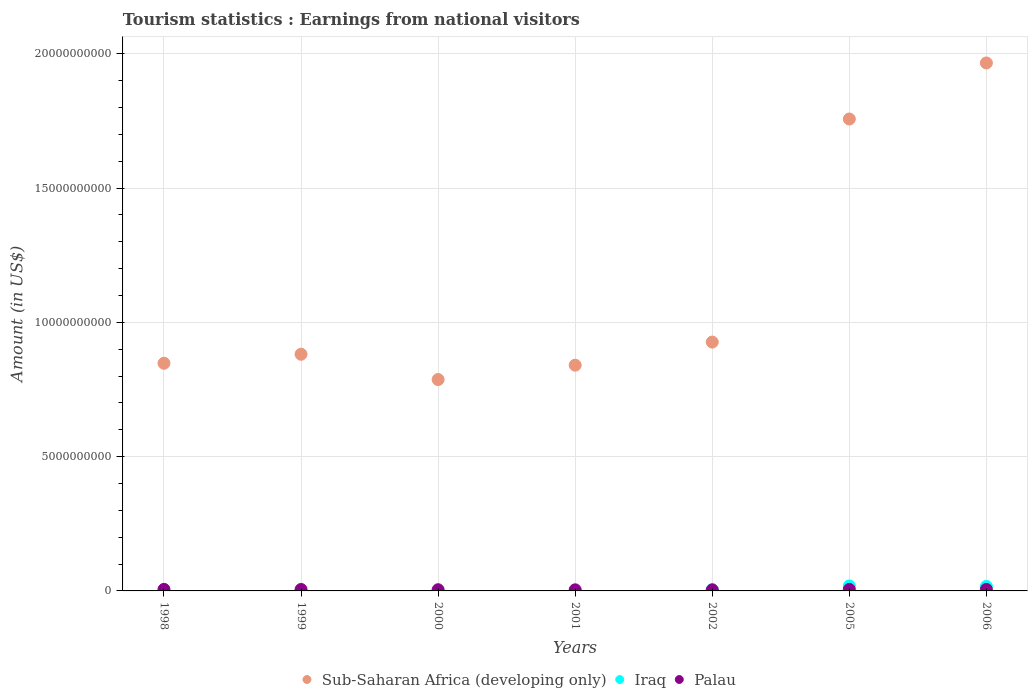What is the earnings from national visitors in Iraq in 2006?
Your answer should be compact. 1.70e+08. Across all years, what is the maximum earnings from national visitors in Iraq?
Provide a short and direct response. 1.86e+08. Across all years, what is the minimum earnings from national visitors in Palau?
Your answer should be very brief. 4.00e+07. In which year was the earnings from national visitors in Palau minimum?
Ensure brevity in your answer.  2002. What is the total earnings from national visitors in Palau in the graph?
Your response must be concise. 3.53e+08. What is the difference between the earnings from national visitors in Iraq in 2000 and that in 2001?
Offer a terse response. -1.30e+07. What is the difference between the earnings from national visitors in Iraq in 2006 and the earnings from national visitors in Palau in 2000?
Keep it short and to the point. 1.25e+08. What is the average earnings from national visitors in Sub-Saharan Africa (developing only) per year?
Your response must be concise. 1.14e+1. In the year 2006, what is the difference between the earnings from national visitors in Sub-Saharan Africa (developing only) and earnings from national visitors in Iraq?
Ensure brevity in your answer.  1.95e+1. What is the ratio of the earnings from national visitors in Iraq in 2005 to that in 2006?
Offer a very short reply. 1.09. Is the difference between the earnings from national visitors in Sub-Saharan Africa (developing only) in 2001 and 2005 greater than the difference between the earnings from national visitors in Iraq in 2001 and 2005?
Provide a succinct answer. No. What is the difference between the highest and the second highest earnings from national visitors in Iraq?
Offer a very short reply. 1.60e+07. What is the difference between the highest and the lowest earnings from national visitors in Palau?
Offer a terse response. 1.80e+07. In how many years, is the earnings from national visitors in Palau greater than the average earnings from national visitors in Palau taken over all years?
Ensure brevity in your answer.  4. Does the earnings from national visitors in Palau monotonically increase over the years?
Offer a terse response. No. Is the earnings from national visitors in Palau strictly greater than the earnings from national visitors in Sub-Saharan Africa (developing only) over the years?
Your answer should be compact. No. Is the earnings from national visitors in Sub-Saharan Africa (developing only) strictly less than the earnings from national visitors in Iraq over the years?
Your answer should be very brief. No. How many years are there in the graph?
Keep it short and to the point. 7. Does the graph contain any zero values?
Your answer should be compact. No. Does the graph contain grids?
Your answer should be very brief. Yes. Where does the legend appear in the graph?
Keep it short and to the point. Bottom center. How many legend labels are there?
Offer a terse response. 3. How are the legend labels stacked?
Offer a terse response. Horizontal. What is the title of the graph?
Your answer should be compact. Tourism statistics : Earnings from national visitors. Does "Lesotho" appear as one of the legend labels in the graph?
Your answer should be very brief. No. What is the Amount (in US$) of Sub-Saharan Africa (developing only) in 1998?
Make the answer very short. 8.48e+09. What is the Amount (in US$) of Iraq in 1998?
Keep it short and to the point. 1.50e+07. What is the Amount (in US$) of Palau in 1998?
Offer a very short reply. 5.80e+07. What is the Amount (in US$) in Sub-Saharan Africa (developing only) in 1999?
Your answer should be very brief. 8.81e+09. What is the Amount (in US$) of Palau in 1999?
Give a very brief answer. 5.40e+07. What is the Amount (in US$) in Sub-Saharan Africa (developing only) in 2000?
Ensure brevity in your answer.  7.87e+09. What is the Amount (in US$) in Palau in 2000?
Provide a succinct answer. 4.50e+07. What is the Amount (in US$) of Sub-Saharan Africa (developing only) in 2001?
Your answer should be compact. 8.41e+09. What is the Amount (in US$) in Iraq in 2001?
Ensure brevity in your answer.  1.50e+07. What is the Amount (in US$) of Palau in 2001?
Your response must be concise. 4.10e+07. What is the Amount (in US$) in Sub-Saharan Africa (developing only) in 2002?
Keep it short and to the point. 9.27e+09. What is the Amount (in US$) in Iraq in 2002?
Make the answer very short. 4.50e+07. What is the Amount (in US$) of Palau in 2002?
Your answer should be very brief. 4.00e+07. What is the Amount (in US$) in Sub-Saharan Africa (developing only) in 2005?
Ensure brevity in your answer.  1.76e+1. What is the Amount (in US$) in Iraq in 2005?
Offer a terse response. 1.86e+08. What is the Amount (in US$) of Palau in 2005?
Keep it short and to the point. 5.70e+07. What is the Amount (in US$) of Sub-Saharan Africa (developing only) in 2006?
Keep it short and to the point. 1.97e+1. What is the Amount (in US$) of Iraq in 2006?
Provide a succinct answer. 1.70e+08. What is the Amount (in US$) of Palau in 2006?
Offer a very short reply. 5.80e+07. Across all years, what is the maximum Amount (in US$) in Sub-Saharan Africa (developing only)?
Provide a short and direct response. 1.97e+1. Across all years, what is the maximum Amount (in US$) of Iraq?
Offer a terse response. 1.86e+08. Across all years, what is the maximum Amount (in US$) in Palau?
Keep it short and to the point. 5.80e+07. Across all years, what is the minimum Amount (in US$) of Sub-Saharan Africa (developing only)?
Your answer should be very brief. 7.87e+09. Across all years, what is the minimum Amount (in US$) of Iraq?
Offer a very short reply. 1.00e+06. Across all years, what is the minimum Amount (in US$) in Palau?
Keep it short and to the point. 4.00e+07. What is the total Amount (in US$) of Sub-Saharan Africa (developing only) in the graph?
Make the answer very short. 8.01e+1. What is the total Amount (in US$) of Iraq in the graph?
Provide a succinct answer. 4.34e+08. What is the total Amount (in US$) in Palau in the graph?
Offer a very short reply. 3.53e+08. What is the difference between the Amount (in US$) in Sub-Saharan Africa (developing only) in 1998 and that in 1999?
Offer a very short reply. -3.36e+08. What is the difference between the Amount (in US$) of Iraq in 1998 and that in 1999?
Keep it short and to the point. 1.40e+07. What is the difference between the Amount (in US$) of Sub-Saharan Africa (developing only) in 1998 and that in 2000?
Your response must be concise. 6.06e+08. What is the difference between the Amount (in US$) in Iraq in 1998 and that in 2000?
Ensure brevity in your answer.  1.30e+07. What is the difference between the Amount (in US$) in Palau in 1998 and that in 2000?
Provide a short and direct response. 1.30e+07. What is the difference between the Amount (in US$) of Sub-Saharan Africa (developing only) in 1998 and that in 2001?
Make the answer very short. 7.12e+07. What is the difference between the Amount (in US$) of Palau in 1998 and that in 2001?
Provide a short and direct response. 1.70e+07. What is the difference between the Amount (in US$) of Sub-Saharan Africa (developing only) in 1998 and that in 2002?
Your answer should be very brief. -7.90e+08. What is the difference between the Amount (in US$) in Iraq in 1998 and that in 2002?
Offer a terse response. -3.00e+07. What is the difference between the Amount (in US$) of Palau in 1998 and that in 2002?
Your answer should be compact. 1.80e+07. What is the difference between the Amount (in US$) in Sub-Saharan Africa (developing only) in 1998 and that in 2005?
Make the answer very short. -9.10e+09. What is the difference between the Amount (in US$) in Iraq in 1998 and that in 2005?
Offer a terse response. -1.71e+08. What is the difference between the Amount (in US$) of Sub-Saharan Africa (developing only) in 1998 and that in 2006?
Offer a terse response. -1.12e+1. What is the difference between the Amount (in US$) in Iraq in 1998 and that in 2006?
Keep it short and to the point. -1.55e+08. What is the difference between the Amount (in US$) of Sub-Saharan Africa (developing only) in 1999 and that in 2000?
Offer a terse response. 9.42e+08. What is the difference between the Amount (in US$) of Iraq in 1999 and that in 2000?
Keep it short and to the point. -1.00e+06. What is the difference between the Amount (in US$) of Palau in 1999 and that in 2000?
Ensure brevity in your answer.  9.00e+06. What is the difference between the Amount (in US$) of Sub-Saharan Africa (developing only) in 1999 and that in 2001?
Provide a short and direct response. 4.07e+08. What is the difference between the Amount (in US$) in Iraq in 1999 and that in 2001?
Give a very brief answer. -1.40e+07. What is the difference between the Amount (in US$) in Palau in 1999 and that in 2001?
Keep it short and to the point. 1.30e+07. What is the difference between the Amount (in US$) of Sub-Saharan Africa (developing only) in 1999 and that in 2002?
Your answer should be compact. -4.54e+08. What is the difference between the Amount (in US$) of Iraq in 1999 and that in 2002?
Your answer should be compact. -4.40e+07. What is the difference between the Amount (in US$) in Palau in 1999 and that in 2002?
Your answer should be very brief. 1.40e+07. What is the difference between the Amount (in US$) of Sub-Saharan Africa (developing only) in 1999 and that in 2005?
Provide a short and direct response. -8.76e+09. What is the difference between the Amount (in US$) of Iraq in 1999 and that in 2005?
Ensure brevity in your answer.  -1.85e+08. What is the difference between the Amount (in US$) of Sub-Saharan Africa (developing only) in 1999 and that in 2006?
Provide a succinct answer. -1.08e+1. What is the difference between the Amount (in US$) in Iraq in 1999 and that in 2006?
Keep it short and to the point. -1.69e+08. What is the difference between the Amount (in US$) of Palau in 1999 and that in 2006?
Make the answer very short. -4.00e+06. What is the difference between the Amount (in US$) of Sub-Saharan Africa (developing only) in 2000 and that in 2001?
Provide a short and direct response. -5.35e+08. What is the difference between the Amount (in US$) of Iraq in 2000 and that in 2001?
Provide a short and direct response. -1.30e+07. What is the difference between the Amount (in US$) in Palau in 2000 and that in 2001?
Provide a short and direct response. 4.00e+06. What is the difference between the Amount (in US$) of Sub-Saharan Africa (developing only) in 2000 and that in 2002?
Ensure brevity in your answer.  -1.40e+09. What is the difference between the Amount (in US$) in Iraq in 2000 and that in 2002?
Make the answer very short. -4.30e+07. What is the difference between the Amount (in US$) in Palau in 2000 and that in 2002?
Your answer should be very brief. 5.00e+06. What is the difference between the Amount (in US$) in Sub-Saharan Africa (developing only) in 2000 and that in 2005?
Provide a succinct answer. -9.70e+09. What is the difference between the Amount (in US$) of Iraq in 2000 and that in 2005?
Your response must be concise. -1.84e+08. What is the difference between the Amount (in US$) in Palau in 2000 and that in 2005?
Your answer should be compact. -1.20e+07. What is the difference between the Amount (in US$) in Sub-Saharan Africa (developing only) in 2000 and that in 2006?
Your answer should be compact. -1.18e+1. What is the difference between the Amount (in US$) in Iraq in 2000 and that in 2006?
Provide a short and direct response. -1.68e+08. What is the difference between the Amount (in US$) of Palau in 2000 and that in 2006?
Offer a very short reply. -1.30e+07. What is the difference between the Amount (in US$) of Sub-Saharan Africa (developing only) in 2001 and that in 2002?
Your answer should be very brief. -8.61e+08. What is the difference between the Amount (in US$) of Iraq in 2001 and that in 2002?
Offer a terse response. -3.00e+07. What is the difference between the Amount (in US$) in Palau in 2001 and that in 2002?
Offer a terse response. 1.00e+06. What is the difference between the Amount (in US$) of Sub-Saharan Africa (developing only) in 2001 and that in 2005?
Provide a short and direct response. -9.17e+09. What is the difference between the Amount (in US$) of Iraq in 2001 and that in 2005?
Offer a very short reply. -1.71e+08. What is the difference between the Amount (in US$) in Palau in 2001 and that in 2005?
Your answer should be very brief. -1.60e+07. What is the difference between the Amount (in US$) of Sub-Saharan Africa (developing only) in 2001 and that in 2006?
Your answer should be very brief. -1.13e+1. What is the difference between the Amount (in US$) in Iraq in 2001 and that in 2006?
Your answer should be very brief. -1.55e+08. What is the difference between the Amount (in US$) of Palau in 2001 and that in 2006?
Offer a very short reply. -1.70e+07. What is the difference between the Amount (in US$) in Sub-Saharan Africa (developing only) in 2002 and that in 2005?
Ensure brevity in your answer.  -8.31e+09. What is the difference between the Amount (in US$) in Iraq in 2002 and that in 2005?
Your response must be concise. -1.41e+08. What is the difference between the Amount (in US$) in Palau in 2002 and that in 2005?
Provide a short and direct response. -1.70e+07. What is the difference between the Amount (in US$) in Sub-Saharan Africa (developing only) in 2002 and that in 2006?
Ensure brevity in your answer.  -1.04e+1. What is the difference between the Amount (in US$) in Iraq in 2002 and that in 2006?
Keep it short and to the point. -1.25e+08. What is the difference between the Amount (in US$) of Palau in 2002 and that in 2006?
Your answer should be compact. -1.80e+07. What is the difference between the Amount (in US$) in Sub-Saharan Africa (developing only) in 2005 and that in 2006?
Provide a succinct answer. -2.09e+09. What is the difference between the Amount (in US$) of Iraq in 2005 and that in 2006?
Your answer should be compact. 1.60e+07. What is the difference between the Amount (in US$) in Palau in 2005 and that in 2006?
Provide a short and direct response. -1.00e+06. What is the difference between the Amount (in US$) in Sub-Saharan Africa (developing only) in 1998 and the Amount (in US$) in Iraq in 1999?
Offer a terse response. 8.48e+09. What is the difference between the Amount (in US$) in Sub-Saharan Africa (developing only) in 1998 and the Amount (in US$) in Palau in 1999?
Offer a very short reply. 8.42e+09. What is the difference between the Amount (in US$) of Iraq in 1998 and the Amount (in US$) of Palau in 1999?
Give a very brief answer. -3.90e+07. What is the difference between the Amount (in US$) of Sub-Saharan Africa (developing only) in 1998 and the Amount (in US$) of Iraq in 2000?
Ensure brevity in your answer.  8.48e+09. What is the difference between the Amount (in US$) of Sub-Saharan Africa (developing only) in 1998 and the Amount (in US$) of Palau in 2000?
Give a very brief answer. 8.43e+09. What is the difference between the Amount (in US$) in Iraq in 1998 and the Amount (in US$) in Palau in 2000?
Make the answer very short. -3.00e+07. What is the difference between the Amount (in US$) of Sub-Saharan Africa (developing only) in 1998 and the Amount (in US$) of Iraq in 2001?
Provide a succinct answer. 8.46e+09. What is the difference between the Amount (in US$) in Sub-Saharan Africa (developing only) in 1998 and the Amount (in US$) in Palau in 2001?
Keep it short and to the point. 8.44e+09. What is the difference between the Amount (in US$) in Iraq in 1998 and the Amount (in US$) in Palau in 2001?
Your response must be concise. -2.60e+07. What is the difference between the Amount (in US$) of Sub-Saharan Africa (developing only) in 1998 and the Amount (in US$) of Iraq in 2002?
Provide a succinct answer. 8.43e+09. What is the difference between the Amount (in US$) of Sub-Saharan Africa (developing only) in 1998 and the Amount (in US$) of Palau in 2002?
Provide a succinct answer. 8.44e+09. What is the difference between the Amount (in US$) in Iraq in 1998 and the Amount (in US$) in Palau in 2002?
Offer a very short reply. -2.50e+07. What is the difference between the Amount (in US$) of Sub-Saharan Africa (developing only) in 1998 and the Amount (in US$) of Iraq in 2005?
Provide a succinct answer. 8.29e+09. What is the difference between the Amount (in US$) of Sub-Saharan Africa (developing only) in 1998 and the Amount (in US$) of Palau in 2005?
Keep it short and to the point. 8.42e+09. What is the difference between the Amount (in US$) of Iraq in 1998 and the Amount (in US$) of Palau in 2005?
Give a very brief answer. -4.20e+07. What is the difference between the Amount (in US$) of Sub-Saharan Africa (developing only) in 1998 and the Amount (in US$) of Iraq in 2006?
Provide a short and direct response. 8.31e+09. What is the difference between the Amount (in US$) of Sub-Saharan Africa (developing only) in 1998 and the Amount (in US$) of Palau in 2006?
Offer a terse response. 8.42e+09. What is the difference between the Amount (in US$) of Iraq in 1998 and the Amount (in US$) of Palau in 2006?
Make the answer very short. -4.30e+07. What is the difference between the Amount (in US$) of Sub-Saharan Africa (developing only) in 1999 and the Amount (in US$) of Iraq in 2000?
Your answer should be very brief. 8.81e+09. What is the difference between the Amount (in US$) of Sub-Saharan Africa (developing only) in 1999 and the Amount (in US$) of Palau in 2000?
Keep it short and to the point. 8.77e+09. What is the difference between the Amount (in US$) in Iraq in 1999 and the Amount (in US$) in Palau in 2000?
Offer a terse response. -4.40e+07. What is the difference between the Amount (in US$) in Sub-Saharan Africa (developing only) in 1999 and the Amount (in US$) in Iraq in 2001?
Offer a very short reply. 8.80e+09. What is the difference between the Amount (in US$) in Sub-Saharan Africa (developing only) in 1999 and the Amount (in US$) in Palau in 2001?
Provide a succinct answer. 8.77e+09. What is the difference between the Amount (in US$) of Iraq in 1999 and the Amount (in US$) of Palau in 2001?
Ensure brevity in your answer.  -4.00e+07. What is the difference between the Amount (in US$) of Sub-Saharan Africa (developing only) in 1999 and the Amount (in US$) of Iraq in 2002?
Keep it short and to the point. 8.77e+09. What is the difference between the Amount (in US$) of Sub-Saharan Africa (developing only) in 1999 and the Amount (in US$) of Palau in 2002?
Provide a short and direct response. 8.77e+09. What is the difference between the Amount (in US$) in Iraq in 1999 and the Amount (in US$) in Palau in 2002?
Offer a very short reply. -3.90e+07. What is the difference between the Amount (in US$) in Sub-Saharan Africa (developing only) in 1999 and the Amount (in US$) in Iraq in 2005?
Your response must be concise. 8.63e+09. What is the difference between the Amount (in US$) in Sub-Saharan Africa (developing only) in 1999 and the Amount (in US$) in Palau in 2005?
Give a very brief answer. 8.76e+09. What is the difference between the Amount (in US$) in Iraq in 1999 and the Amount (in US$) in Palau in 2005?
Provide a succinct answer. -5.60e+07. What is the difference between the Amount (in US$) of Sub-Saharan Africa (developing only) in 1999 and the Amount (in US$) of Iraq in 2006?
Keep it short and to the point. 8.64e+09. What is the difference between the Amount (in US$) in Sub-Saharan Africa (developing only) in 1999 and the Amount (in US$) in Palau in 2006?
Provide a short and direct response. 8.75e+09. What is the difference between the Amount (in US$) of Iraq in 1999 and the Amount (in US$) of Palau in 2006?
Offer a terse response. -5.70e+07. What is the difference between the Amount (in US$) in Sub-Saharan Africa (developing only) in 2000 and the Amount (in US$) in Iraq in 2001?
Give a very brief answer. 7.86e+09. What is the difference between the Amount (in US$) in Sub-Saharan Africa (developing only) in 2000 and the Amount (in US$) in Palau in 2001?
Provide a short and direct response. 7.83e+09. What is the difference between the Amount (in US$) in Iraq in 2000 and the Amount (in US$) in Palau in 2001?
Give a very brief answer. -3.90e+07. What is the difference between the Amount (in US$) in Sub-Saharan Africa (developing only) in 2000 and the Amount (in US$) in Iraq in 2002?
Your response must be concise. 7.83e+09. What is the difference between the Amount (in US$) of Sub-Saharan Africa (developing only) in 2000 and the Amount (in US$) of Palau in 2002?
Your answer should be compact. 7.83e+09. What is the difference between the Amount (in US$) in Iraq in 2000 and the Amount (in US$) in Palau in 2002?
Ensure brevity in your answer.  -3.80e+07. What is the difference between the Amount (in US$) in Sub-Saharan Africa (developing only) in 2000 and the Amount (in US$) in Iraq in 2005?
Your answer should be compact. 7.69e+09. What is the difference between the Amount (in US$) of Sub-Saharan Africa (developing only) in 2000 and the Amount (in US$) of Palau in 2005?
Provide a short and direct response. 7.81e+09. What is the difference between the Amount (in US$) in Iraq in 2000 and the Amount (in US$) in Palau in 2005?
Provide a succinct answer. -5.50e+07. What is the difference between the Amount (in US$) of Sub-Saharan Africa (developing only) in 2000 and the Amount (in US$) of Iraq in 2006?
Provide a succinct answer. 7.70e+09. What is the difference between the Amount (in US$) of Sub-Saharan Africa (developing only) in 2000 and the Amount (in US$) of Palau in 2006?
Provide a short and direct response. 7.81e+09. What is the difference between the Amount (in US$) of Iraq in 2000 and the Amount (in US$) of Palau in 2006?
Your answer should be compact. -5.60e+07. What is the difference between the Amount (in US$) in Sub-Saharan Africa (developing only) in 2001 and the Amount (in US$) in Iraq in 2002?
Give a very brief answer. 8.36e+09. What is the difference between the Amount (in US$) in Sub-Saharan Africa (developing only) in 2001 and the Amount (in US$) in Palau in 2002?
Provide a succinct answer. 8.37e+09. What is the difference between the Amount (in US$) in Iraq in 2001 and the Amount (in US$) in Palau in 2002?
Offer a very short reply. -2.50e+07. What is the difference between the Amount (in US$) of Sub-Saharan Africa (developing only) in 2001 and the Amount (in US$) of Iraq in 2005?
Offer a very short reply. 8.22e+09. What is the difference between the Amount (in US$) of Sub-Saharan Africa (developing only) in 2001 and the Amount (in US$) of Palau in 2005?
Offer a very short reply. 8.35e+09. What is the difference between the Amount (in US$) of Iraq in 2001 and the Amount (in US$) of Palau in 2005?
Your response must be concise. -4.20e+07. What is the difference between the Amount (in US$) of Sub-Saharan Africa (developing only) in 2001 and the Amount (in US$) of Iraq in 2006?
Ensure brevity in your answer.  8.24e+09. What is the difference between the Amount (in US$) of Sub-Saharan Africa (developing only) in 2001 and the Amount (in US$) of Palau in 2006?
Your response must be concise. 8.35e+09. What is the difference between the Amount (in US$) of Iraq in 2001 and the Amount (in US$) of Palau in 2006?
Make the answer very short. -4.30e+07. What is the difference between the Amount (in US$) of Sub-Saharan Africa (developing only) in 2002 and the Amount (in US$) of Iraq in 2005?
Offer a terse response. 9.08e+09. What is the difference between the Amount (in US$) of Sub-Saharan Africa (developing only) in 2002 and the Amount (in US$) of Palau in 2005?
Provide a succinct answer. 9.21e+09. What is the difference between the Amount (in US$) of Iraq in 2002 and the Amount (in US$) of Palau in 2005?
Make the answer very short. -1.20e+07. What is the difference between the Amount (in US$) in Sub-Saharan Africa (developing only) in 2002 and the Amount (in US$) in Iraq in 2006?
Your answer should be compact. 9.10e+09. What is the difference between the Amount (in US$) of Sub-Saharan Africa (developing only) in 2002 and the Amount (in US$) of Palau in 2006?
Your answer should be very brief. 9.21e+09. What is the difference between the Amount (in US$) of Iraq in 2002 and the Amount (in US$) of Palau in 2006?
Your answer should be very brief. -1.30e+07. What is the difference between the Amount (in US$) of Sub-Saharan Africa (developing only) in 2005 and the Amount (in US$) of Iraq in 2006?
Keep it short and to the point. 1.74e+1. What is the difference between the Amount (in US$) of Sub-Saharan Africa (developing only) in 2005 and the Amount (in US$) of Palau in 2006?
Offer a very short reply. 1.75e+1. What is the difference between the Amount (in US$) of Iraq in 2005 and the Amount (in US$) of Palau in 2006?
Provide a short and direct response. 1.28e+08. What is the average Amount (in US$) in Sub-Saharan Africa (developing only) per year?
Your answer should be very brief. 1.14e+1. What is the average Amount (in US$) of Iraq per year?
Your response must be concise. 6.20e+07. What is the average Amount (in US$) of Palau per year?
Ensure brevity in your answer.  5.04e+07. In the year 1998, what is the difference between the Amount (in US$) in Sub-Saharan Africa (developing only) and Amount (in US$) in Iraq?
Offer a terse response. 8.46e+09. In the year 1998, what is the difference between the Amount (in US$) in Sub-Saharan Africa (developing only) and Amount (in US$) in Palau?
Your answer should be compact. 8.42e+09. In the year 1998, what is the difference between the Amount (in US$) of Iraq and Amount (in US$) of Palau?
Ensure brevity in your answer.  -4.30e+07. In the year 1999, what is the difference between the Amount (in US$) in Sub-Saharan Africa (developing only) and Amount (in US$) in Iraq?
Provide a short and direct response. 8.81e+09. In the year 1999, what is the difference between the Amount (in US$) in Sub-Saharan Africa (developing only) and Amount (in US$) in Palau?
Provide a succinct answer. 8.76e+09. In the year 1999, what is the difference between the Amount (in US$) in Iraq and Amount (in US$) in Palau?
Provide a succinct answer. -5.30e+07. In the year 2000, what is the difference between the Amount (in US$) in Sub-Saharan Africa (developing only) and Amount (in US$) in Iraq?
Offer a terse response. 7.87e+09. In the year 2000, what is the difference between the Amount (in US$) in Sub-Saharan Africa (developing only) and Amount (in US$) in Palau?
Provide a short and direct response. 7.83e+09. In the year 2000, what is the difference between the Amount (in US$) in Iraq and Amount (in US$) in Palau?
Provide a short and direct response. -4.30e+07. In the year 2001, what is the difference between the Amount (in US$) of Sub-Saharan Africa (developing only) and Amount (in US$) of Iraq?
Provide a succinct answer. 8.39e+09. In the year 2001, what is the difference between the Amount (in US$) in Sub-Saharan Africa (developing only) and Amount (in US$) in Palau?
Make the answer very short. 8.36e+09. In the year 2001, what is the difference between the Amount (in US$) of Iraq and Amount (in US$) of Palau?
Offer a very short reply. -2.60e+07. In the year 2002, what is the difference between the Amount (in US$) of Sub-Saharan Africa (developing only) and Amount (in US$) of Iraq?
Keep it short and to the point. 9.22e+09. In the year 2002, what is the difference between the Amount (in US$) of Sub-Saharan Africa (developing only) and Amount (in US$) of Palau?
Provide a short and direct response. 9.23e+09. In the year 2005, what is the difference between the Amount (in US$) of Sub-Saharan Africa (developing only) and Amount (in US$) of Iraq?
Offer a terse response. 1.74e+1. In the year 2005, what is the difference between the Amount (in US$) of Sub-Saharan Africa (developing only) and Amount (in US$) of Palau?
Provide a succinct answer. 1.75e+1. In the year 2005, what is the difference between the Amount (in US$) of Iraq and Amount (in US$) of Palau?
Offer a very short reply. 1.29e+08. In the year 2006, what is the difference between the Amount (in US$) in Sub-Saharan Africa (developing only) and Amount (in US$) in Iraq?
Make the answer very short. 1.95e+1. In the year 2006, what is the difference between the Amount (in US$) in Sub-Saharan Africa (developing only) and Amount (in US$) in Palau?
Ensure brevity in your answer.  1.96e+1. In the year 2006, what is the difference between the Amount (in US$) in Iraq and Amount (in US$) in Palau?
Offer a very short reply. 1.12e+08. What is the ratio of the Amount (in US$) in Sub-Saharan Africa (developing only) in 1998 to that in 1999?
Give a very brief answer. 0.96. What is the ratio of the Amount (in US$) of Palau in 1998 to that in 1999?
Make the answer very short. 1.07. What is the ratio of the Amount (in US$) in Sub-Saharan Africa (developing only) in 1998 to that in 2000?
Offer a very short reply. 1.08. What is the ratio of the Amount (in US$) of Iraq in 1998 to that in 2000?
Ensure brevity in your answer.  7.5. What is the ratio of the Amount (in US$) in Palau in 1998 to that in 2000?
Keep it short and to the point. 1.29. What is the ratio of the Amount (in US$) of Sub-Saharan Africa (developing only) in 1998 to that in 2001?
Offer a terse response. 1.01. What is the ratio of the Amount (in US$) of Palau in 1998 to that in 2001?
Make the answer very short. 1.41. What is the ratio of the Amount (in US$) in Sub-Saharan Africa (developing only) in 1998 to that in 2002?
Offer a very short reply. 0.91. What is the ratio of the Amount (in US$) of Palau in 1998 to that in 2002?
Give a very brief answer. 1.45. What is the ratio of the Amount (in US$) of Sub-Saharan Africa (developing only) in 1998 to that in 2005?
Keep it short and to the point. 0.48. What is the ratio of the Amount (in US$) in Iraq in 1998 to that in 2005?
Offer a terse response. 0.08. What is the ratio of the Amount (in US$) of Palau in 1998 to that in 2005?
Your response must be concise. 1.02. What is the ratio of the Amount (in US$) of Sub-Saharan Africa (developing only) in 1998 to that in 2006?
Keep it short and to the point. 0.43. What is the ratio of the Amount (in US$) of Iraq in 1998 to that in 2006?
Your answer should be compact. 0.09. What is the ratio of the Amount (in US$) of Palau in 1998 to that in 2006?
Provide a short and direct response. 1. What is the ratio of the Amount (in US$) in Sub-Saharan Africa (developing only) in 1999 to that in 2000?
Your answer should be very brief. 1.12. What is the ratio of the Amount (in US$) in Iraq in 1999 to that in 2000?
Give a very brief answer. 0.5. What is the ratio of the Amount (in US$) in Sub-Saharan Africa (developing only) in 1999 to that in 2001?
Your response must be concise. 1.05. What is the ratio of the Amount (in US$) of Iraq in 1999 to that in 2001?
Make the answer very short. 0.07. What is the ratio of the Amount (in US$) in Palau in 1999 to that in 2001?
Give a very brief answer. 1.32. What is the ratio of the Amount (in US$) in Sub-Saharan Africa (developing only) in 1999 to that in 2002?
Provide a succinct answer. 0.95. What is the ratio of the Amount (in US$) of Iraq in 1999 to that in 2002?
Provide a short and direct response. 0.02. What is the ratio of the Amount (in US$) in Palau in 1999 to that in 2002?
Keep it short and to the point. 1.35. What is the ratio of the Amount (in US$) of Sub-Saharan Africa (developing only) in 1999 to that in 2005?
Offer a terse response. 0.5. What is the ratio of the Amount (in US$) of Iraq in 1999 to that in 2005?
Provide a short and direct response. 0.01. What is the ratio of the Amount (in US$) in Sub-Saharan Africa (developing only) in 1999 to that in 2006?
Provide a succinct answer. 0.45. What is the ratio of the Amount (in US$) of Iraq in 1999 to that in 2006?
Offer a very short reply. 0.01. What is the ratio of the Amount (in US$) in Palau in 1999 to that in 2006?
Offer a very short reply. 0.93. What is the ratio of the Amount (in US$) of Sub-Saharan Africa (developing only) in 2000 to that in 2001?
Make the answer very short. 0.94. What is the ratio of the Amount (in US$) of Iraq in 2000 to that in 2001?
Your answer should be very brief. 0.13. What is the ratio of the Amount (in US$) of Palau in 2000 to that in 2001?
Make the answer very short. 1.1. What is the ratio of the Amount (in US$) in Sub-Saharan Africa (developing only) in 2000 to that in 2002?
Your answer should be compact. 0.85. What is the ratio of the Amount (in US$) in Iraq in 2000 to that in 2002?
Your answer should be compact. 0.04. What is the ratio of the Amount (in US$) of Sub-Saharan Africa (developing only) in 2000 to that in 2005?
Ensure brevity in your answer.  0.45. What is the ratio of the Amount (in US$) in Iraq in 2000 to that in 2005?
Your answer should be compact. 0.01. What is the ratio of the Amount (in US$) of Palau in 2000 to that in 2005?
Keep it short and to the point. 0.79. What is the ratio of the Amount (in US$) of Sub-Saharan Africa (developing only) in 2000 to that in 2006?
Make the answer very short. 0.4. What is the ratio of the Amount (in US$) of Iraq in 2000 to that in 2006?
Provide a succinct answer. 0.01. What is the ratio of the Amount (in US$) of Palau in 2000 to that in 2006?
Provide a succinct answer. 0.78. What is the ratio of the Amount (in US$) in Sub-Saharan Africa (developing only) in 2001 to that in 2002?
Make the answer very short. 0.91. What is the ratio of the Amount (in US$) of Iraq in 2001 to that in 2002?
Make the answer very short. 0.33. What is the ratio of the Amount (in US$) in Palau in 2001 to that in 2002?
Ensure brevity in your answer.  1.02. What is the ratio of the Amount (in US$) in Sub-Saharan Africa (developing only) in 2001 to that in 2005?
Make the answer very short. 0.48. What is the ratio of the Amount (in US$) of Iraq in 2001 to that in 2005?
Your response must be concise. 0.08. What is the ratio of the Amount (in US$) of Palau in 2001 to that in 2005?
Ensure brevity in your answer.  0.72. What is the ratio of the Amount (in US$) of Sub-Saharan Africa (developing only) in 2001 to that in 2006?
Your response must be concise. 0.43. What is the ratio of the Amount (in US$) of Iraq in 2001 to that in 2006?
Offer a very short reply. 0.09. What is the ratio of the Amount (in US$) of Palau in 2001 to that in 2006?
Make the answer very short. 0.71. What is the ratio of the Amount (in US$) in Sub-Saharan Africa (developing only) in 2002 to that in 2005?
Ensure brevity in your answer.  0.53. What is the ratio of the Amount (in US$) in Iraq in 2002 to that in 2005?
Offer a very short reply. 0.24. What is the ratio of the Amount (in US$) of Palau in 2002 to that in 2005?
Give a very brief answer. 0.7. What is the ratio of the Amount (in US$) of Sub-Saharan Africa (developing only) in 2002 to that in 2006?
Provide a succinct answer. 0.47. What is the ratio of the Amount (in US$) in Iraq in 2002 to that in 2006?
Make the answer very short. 0.26. What is the ratio of the Amount (in US$) in Palau in 2002 to that in 2006?
Keep it short and to the point. 0.69. What is the ratio of the Amount (in US$) of Sub-Saharan Africa (developing only) in 2005 to that in 2006?
Give a very brief answer. 0.89. What is the ratio of the Amount (in US$) in Iraq in 2005 to that in 2006?
Your response must be concise. 1.09. What is the ratio of the Amount (in US$) in Palau in 2005 to that in 2006?
Provide a short and direct response. 0.98. What is the difference between the highest and the second highest Amount (in US$) in Sub-Saharan Africa (developing only)?
Provide a short and direct response. 2.09e+09. What is the difference between the highest and the second highest Amount (in US$) of Iraq?
Your response must be concise. 1.60e+07. What is the difference between the highest and the lowest Amount (in US$) of Sub-Saharan Africa (developing only)?
Keep it short and to the point. 1.18e+1. What is the difference between the highest and the lowest Amount (in US$) of Iraq?
Your answer should be very brief. 1.85e+08. What is the difference between the highest and the lowest Amount (in US$) of Palau?
Your response must be concise. 1.80e+07. 